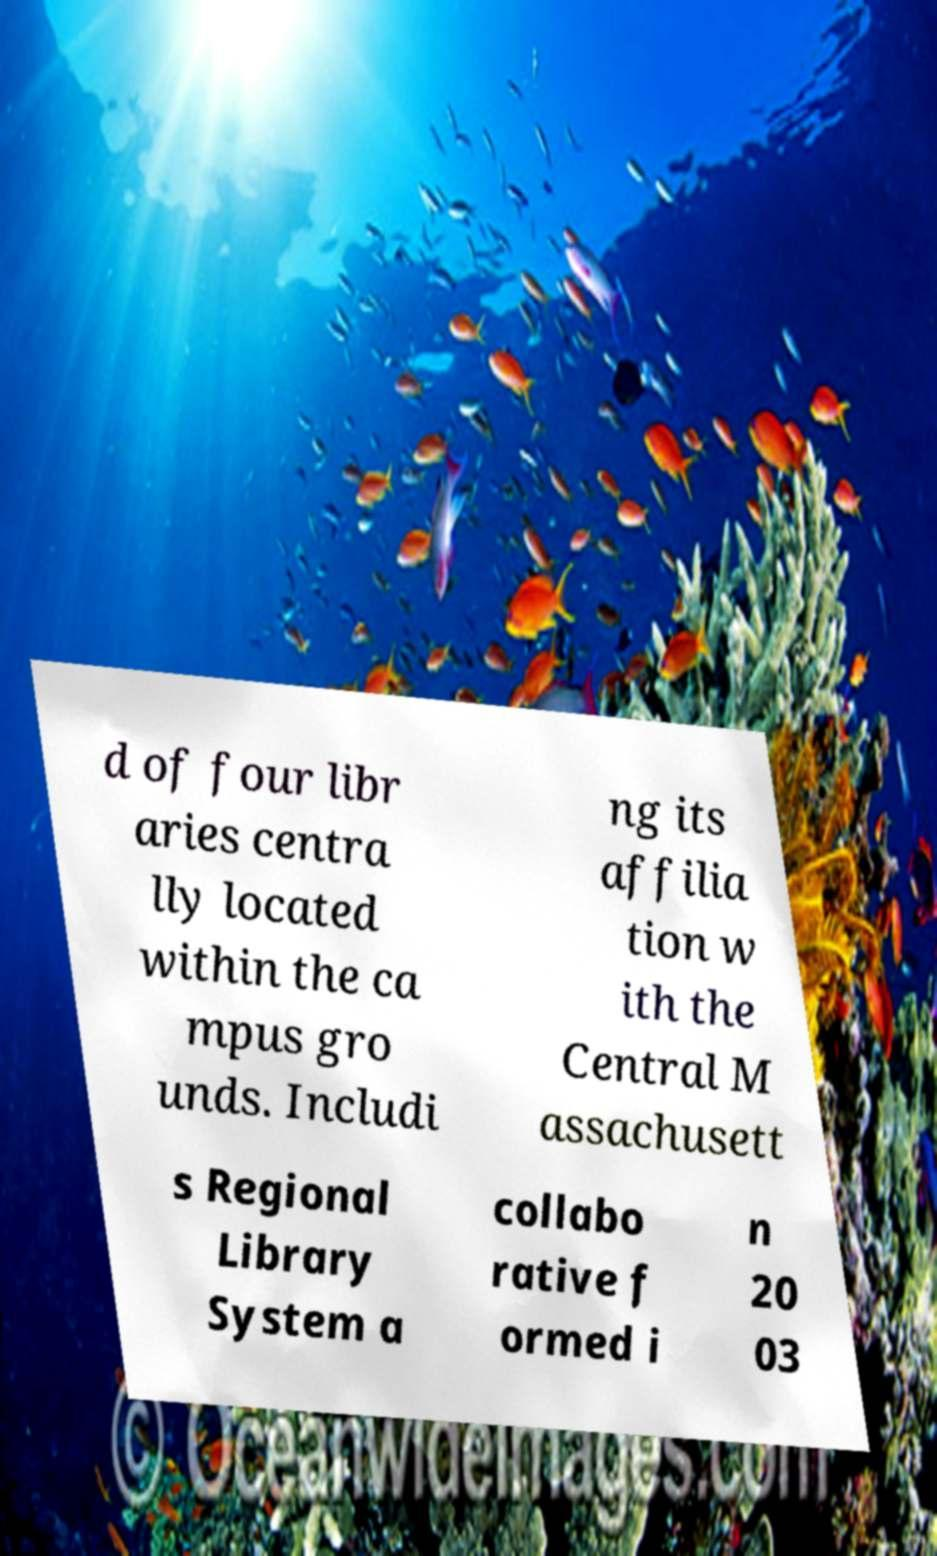I need the written content from this picture converted into text. Can you do that? d of four libr aries centra lly located within the ca mpus gro unds. Includi ng its affilia tion w ith the Central M assachusett s Regional Library System a collabo rative f ormed i n 20 03 